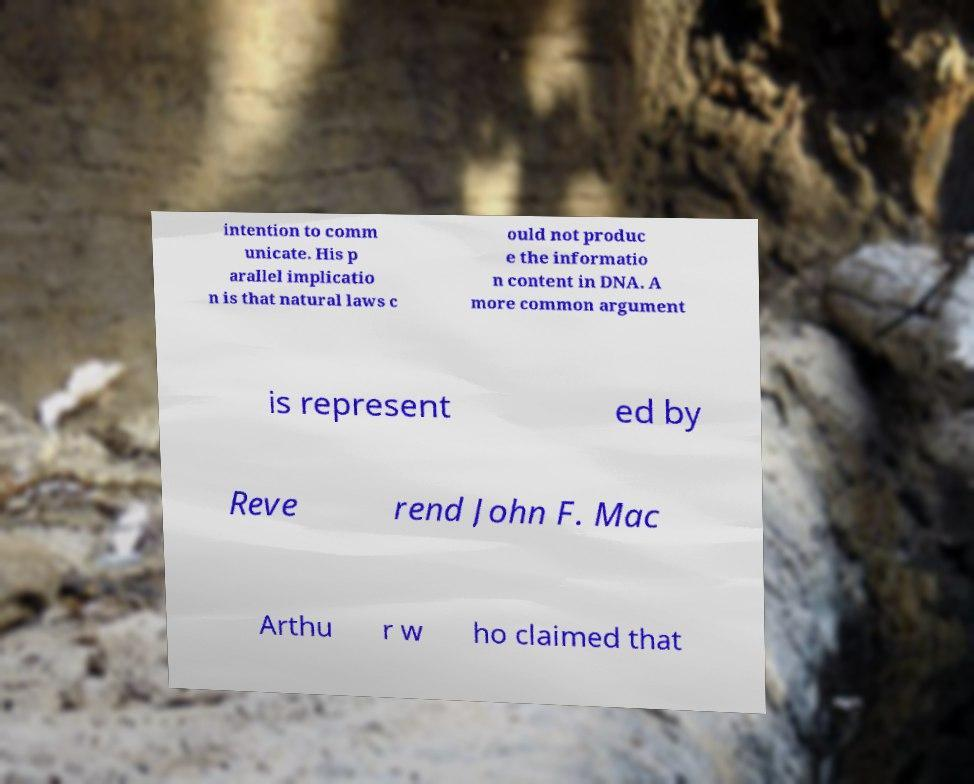For documentation purposes, I need the text within this image transcribed. Could you provide that? intention to comm unicate. His p arallel implicatio n is that natural laws c ould not produc e the informatio n content in DNA. A more common argument is represent ed by Reve rend John F. Mac Arthu r w ho claimed that 